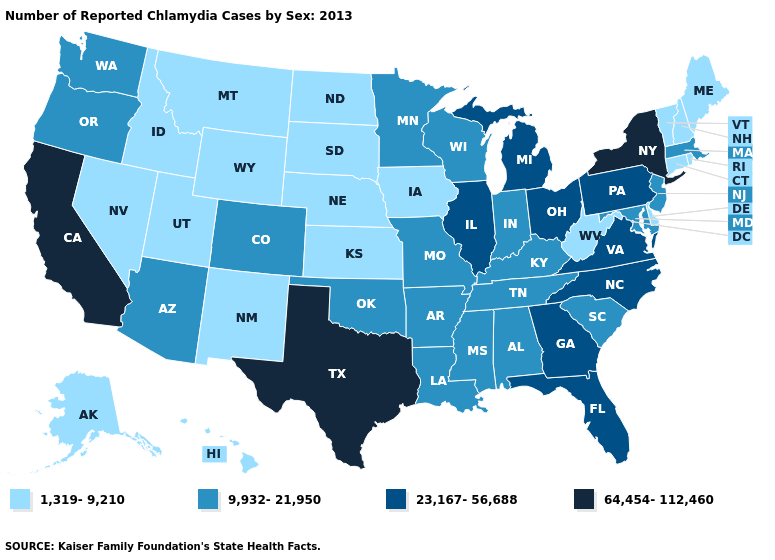Among the states that border Arizona , which have the highest value?
Answer briefly. California. Does California have the highest value in the West?
Keep it brief. Yes. Does the first symbol in the legend represent the smallest category?
Answer briefly. Yes. Which states have the lowest value in the USA?
Answer briefly. Alaska, Connecticut, Delaware, Hawaii, Idaho, Iowa, Kansas, Maine, Montana, Nebraska, Nevada, New Hampshire, New Mexico, North Dakota, Rhode Island, South Dakota, Utah, Vermont, West Virginia, Wyoming. Name the states that have a value in the range 64,454-112,460?
Give a very brief answer. California, New York, Texas. Does Oregon have a higher value than Colorado?
Give a very brief answer. No. What is the highest value in the USA?
Keep it brief. 64,454-112,460. What is the value of Utah?
Answer briefly. 1,319-9,210. What is the lowest value in the USA?
Concise answer only. 1,319-9,210. Does Texas have the highest value in the USA?
Answer briefly. Yes. What is the lowest value in the USA?
Quick response, please. 1,319-9,210. Does the first symbol in the legend represent the smallest category?
Write a very short answer. Yes. Does Wyoming have the lowest value in the USA?
Write a very short answer. Yes. Name the states that have a value in the range 64,454-112,460?
Give a very brief answer. California, New York, Texas. What is the value of Nebraska?
Quick response, please. 1,319-9,210. 